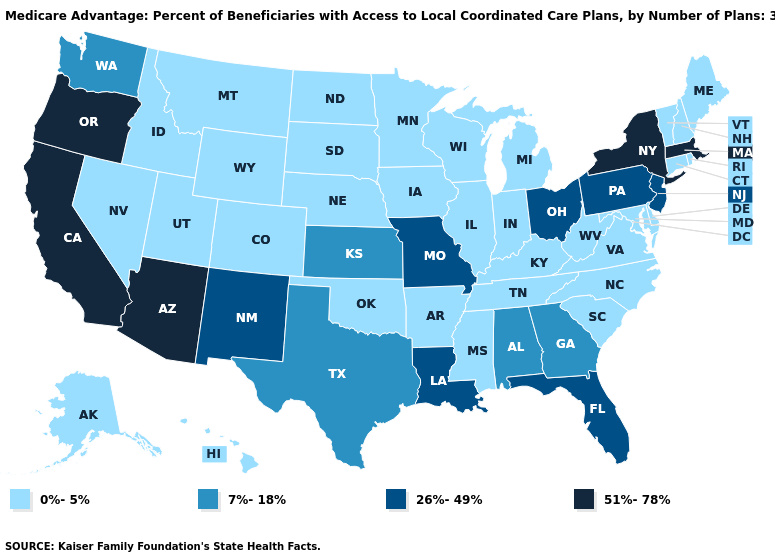What is the lowest value in the USA?
Answer briefly. 0%-5%. What is the value of Louisiana?
Be succinct. 26%-49%. Name the states that have a value in the range 26%-49%?
Write a very short answer. Florida, Louisiana, Missouri, New Jersey, New Mexico, Ohio, Pennsylvania. Name the states that have a value in the range 0%-5%?
Quick response, please. Alaska, Arkansas, Colorado, Connecticut, Delaware, Hawaii, Iowa, Idaho, Illinois, Indiana, Kentucky, Maryland, Maine, Michigan, Minnesota, Mississippi, Montana, North Carolina, North Dakota, Nebraska, New Hampshire, Nevada, Oklahoma, Rhode Island, South Carolina, South Dakota, Tennessee, Utah, Virginia, Vermont, Wisconsin, West Virginia, Wyoming. What is the lowest value in states that border Washington?
Write a very short answer. 0%-5%. Which states hav the highest value in the South?
Answer briefly. Florida, Louisiana. What is the value of Washington?
Write a very short answer. 7%-18%. Among the states that border Oregon , does Idaho have the highest value?
Be succinct. No. Name the states that have a value in the range 26%-49%?
Concise answer only. Florida, Louisiana, Missouri, New Jersey, New Mexico, Ohio, Pennsylvania. Does the map have missing data?
Concise answer only. No. Does Mississippi have a lower value than Wisconsin?
Short answer required. No. What is the value of New York?
Keep it brief. 51%-78%. Does Arkansas have a higher value than Pennsylvania?
Quick response, please. No. Which states have the lowest value in the Northeast?
Short answer required. Connecticut, Maine, New Hampshire, Rhode Island, Vermont. Among the states that border Louisiana , does Mississippi have the lowest value?
Quick response, please. Yes. 